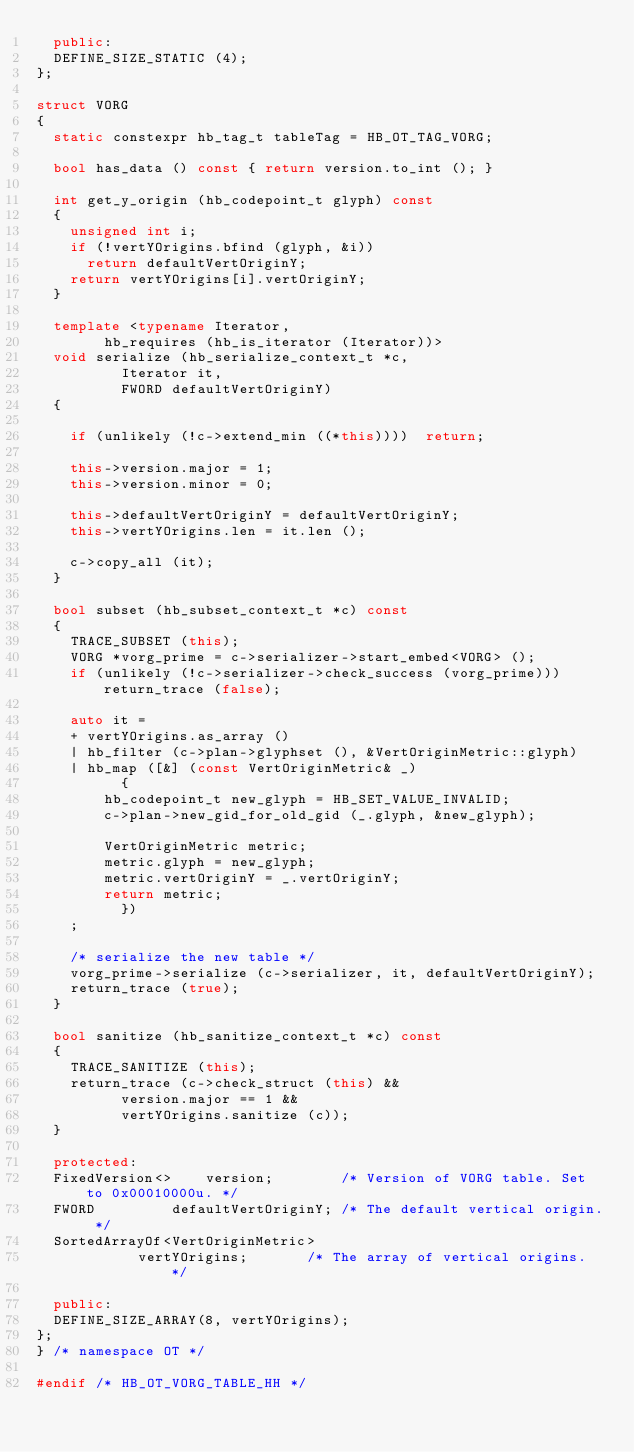Convert code to text. <code><loc_0><loc_0><loc_500><loc_500><_C++_>  public:
  DEFINE_SIZE_STATIC (4);
};

struct VORG
{
  static constexpr hb_tag_t tableTag = HB_OT_TAG_VORG;

  bool has_data () const { return version.to_int (); }

  int get_y_origin (hb_codepoint_t glyph) const
  {
    unsigned int i;
    if (!vertYOrigins.bfind (glyph, &i))
      return defaultVertOriginY;
    return vertYOrigins[i].vertOriginY;
  }

  template <typename Iterator,
	    hb_requires (hb_is_iterator (Iterator))>
  void serialize (hb_serialize_context_t *c,
		  Iterator it,
		  FWORD defaultVertOriginY)
  {

    if (unlikely (!c->extend_min ((*this))))  return;

    this->version.major = 1;
    this->version.minor = 0;

    this->defaultVertOriginY = defaultVertOriginY;
    this->vertYOrigins.len = it.len ();

    c->copy_all (it);
  }

  bool subset (hb_subset_context_t *c) const
  {
    TRACE_SUBSET (this);
    VORG *vorg_prime = c->serializer->start_embed<VORG> ();
    if (unlikely (!c->serializer->check_success (vorg_prime))) return_trace (false);

    auto it =
    + vertYOrigins.as_array ()
    | hb_filter (c->plan->glyphset (), &VertOriginMetric::glyph)
    | hb_map ([&] (const VertOriginMetric& _)
	      {
		hb_codepoint_t new_glyph = HB_SET_VALUE_INVALID;
		c->plan->new_gid_for_old_gid (_.glyph, &new_glyph);

		VertOriginMetric metric;
		metric.glyph = new_glyph;
		metric.vertOriginY = _.vertOriginY;
		return metric;
	      })
    ;

    /* serialize the new table */
    vorg_prime->serialize (c->serializer, it, defaultVertOriginY);
    return_trace (true);
  }

  bool sanitize (hb_sanitize_context_t *c) const
  {
    TRACE_SANITIZE (this);
    return_trace (c->check_struct (this) &&
		  version.major == 1 &&
		  vertYOrigins.sanitize (c));
  }

  protected:
  FixedVersion<>	version;		/* Version of VORG table. Set to 0x00010000u. */
  FWORD			defaultVertOriginY;	/* The default vertical origin. */
  SortedArrayOf<VertOriginMetric>
			vertYOrigins;		/* The array of vertical origins. */

  public:
  DEFINE_SIZE_ARRAY(8, vertYOrigins);
};
} /* namespace OT */

#endif /* HB_OT_VORG_TABLE_HH */
</code> 